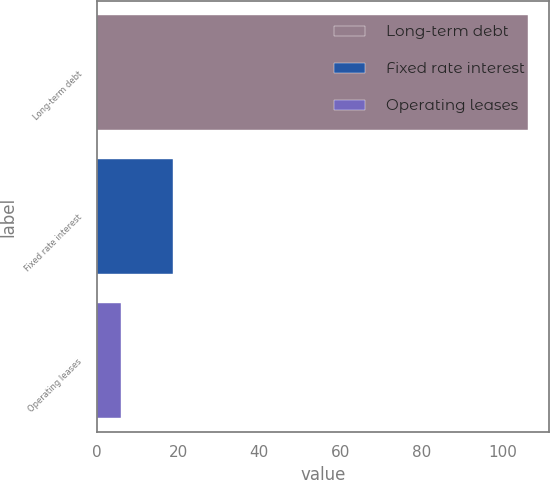<chart> <loc_0><loc_0><loc_500><loc_500><bar_chart><fcel>Long-term debt<fcel>Fixed rate interest<fcel>Operating leases<nl><fcel>106.3<fcel>18.7<fcel>5.8<nl></chart> 